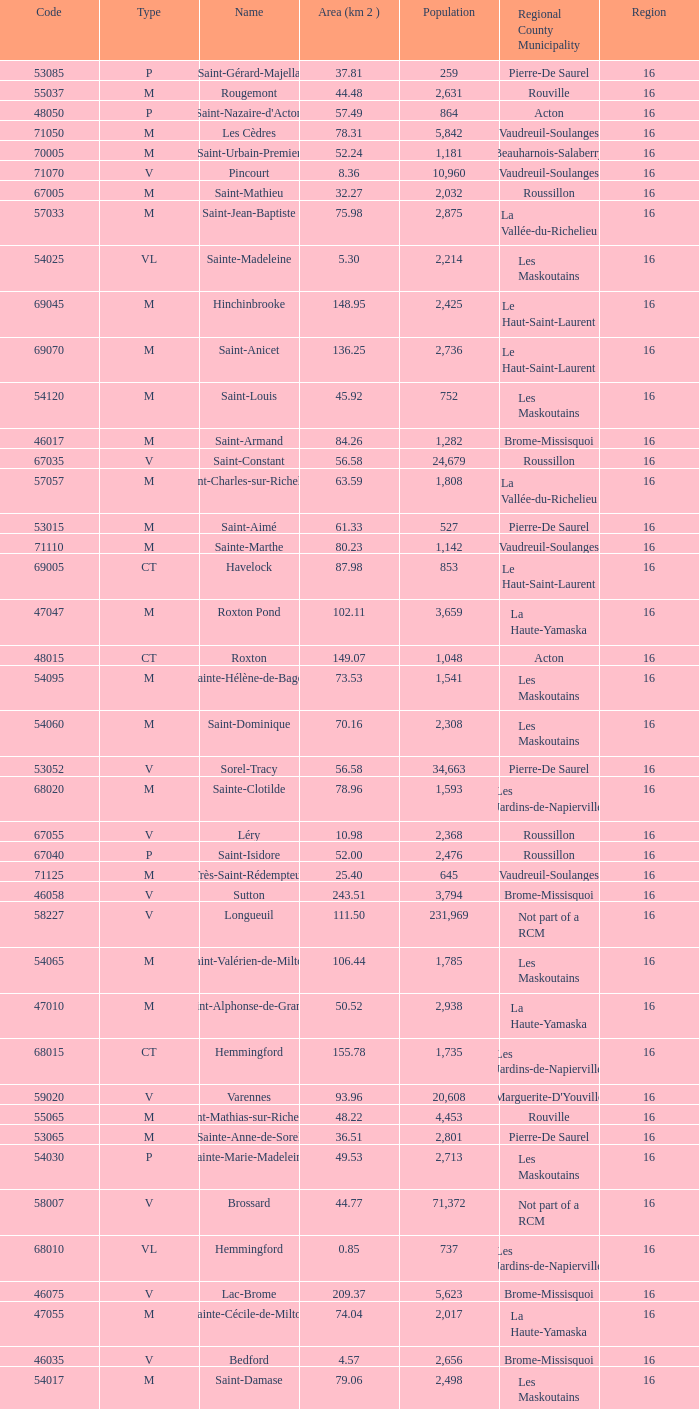What is the code for a Le Haut-Saint-Laurent municipality that has 16 or more regions? None. 